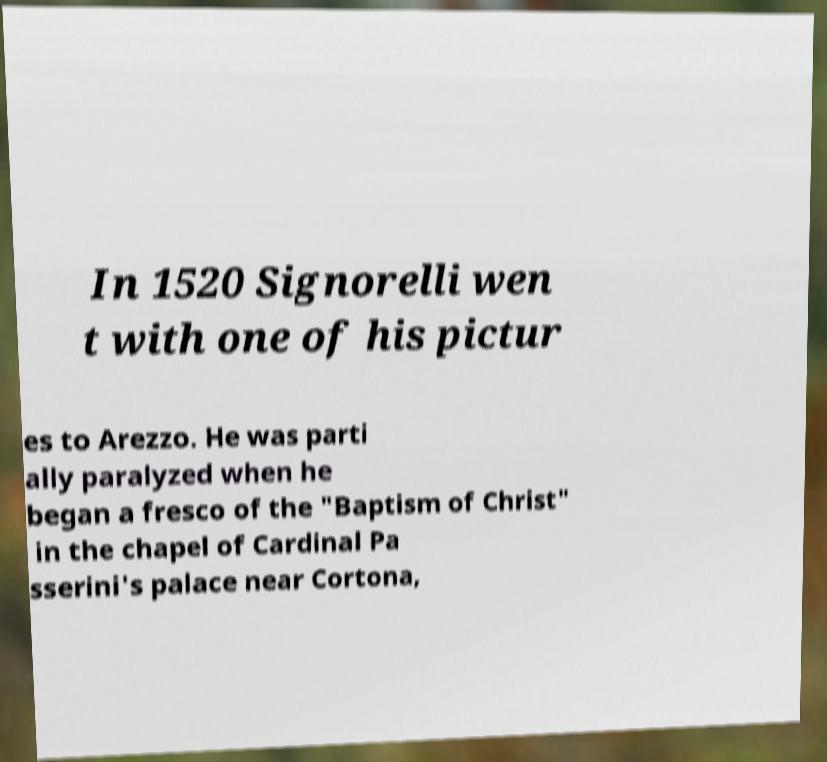There's text embedded in this image that I need extracted. Can you transcribe it verbatim? In 1520 Signorelli wen t with one of his pictur es to Arezzo. He was parti ally paralyzed when he began a fresco of the "Baptism of Christ" in the chapel of Cardinal Pa sserini's palace near Cortona, 